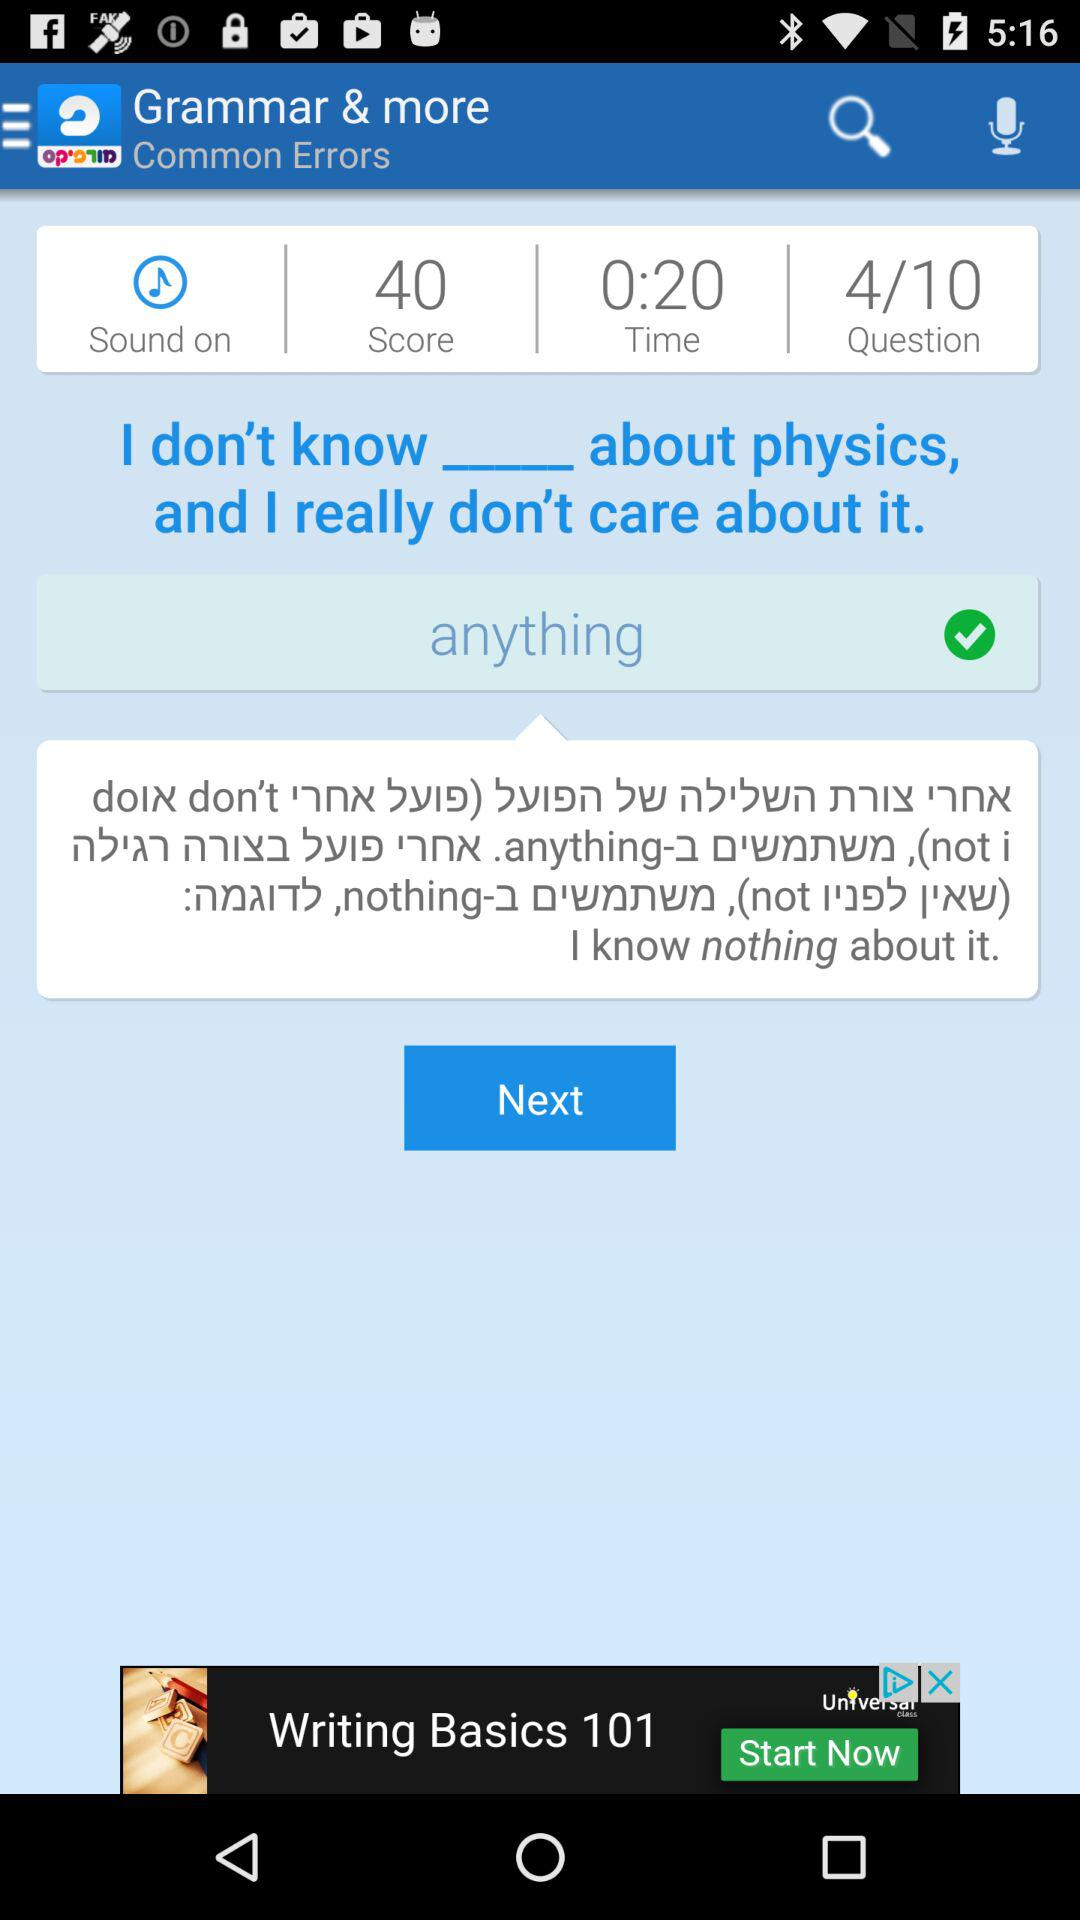What is the app name? The app name is "Morfix - English to Hebrew Tra". 